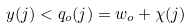Convert formula to latex. <formula><loc_0><loc_0><loc_500><loc_500>y ( j ) < q _ { o } ( j ) = w _ { o } + \chi ( j )</formula> 